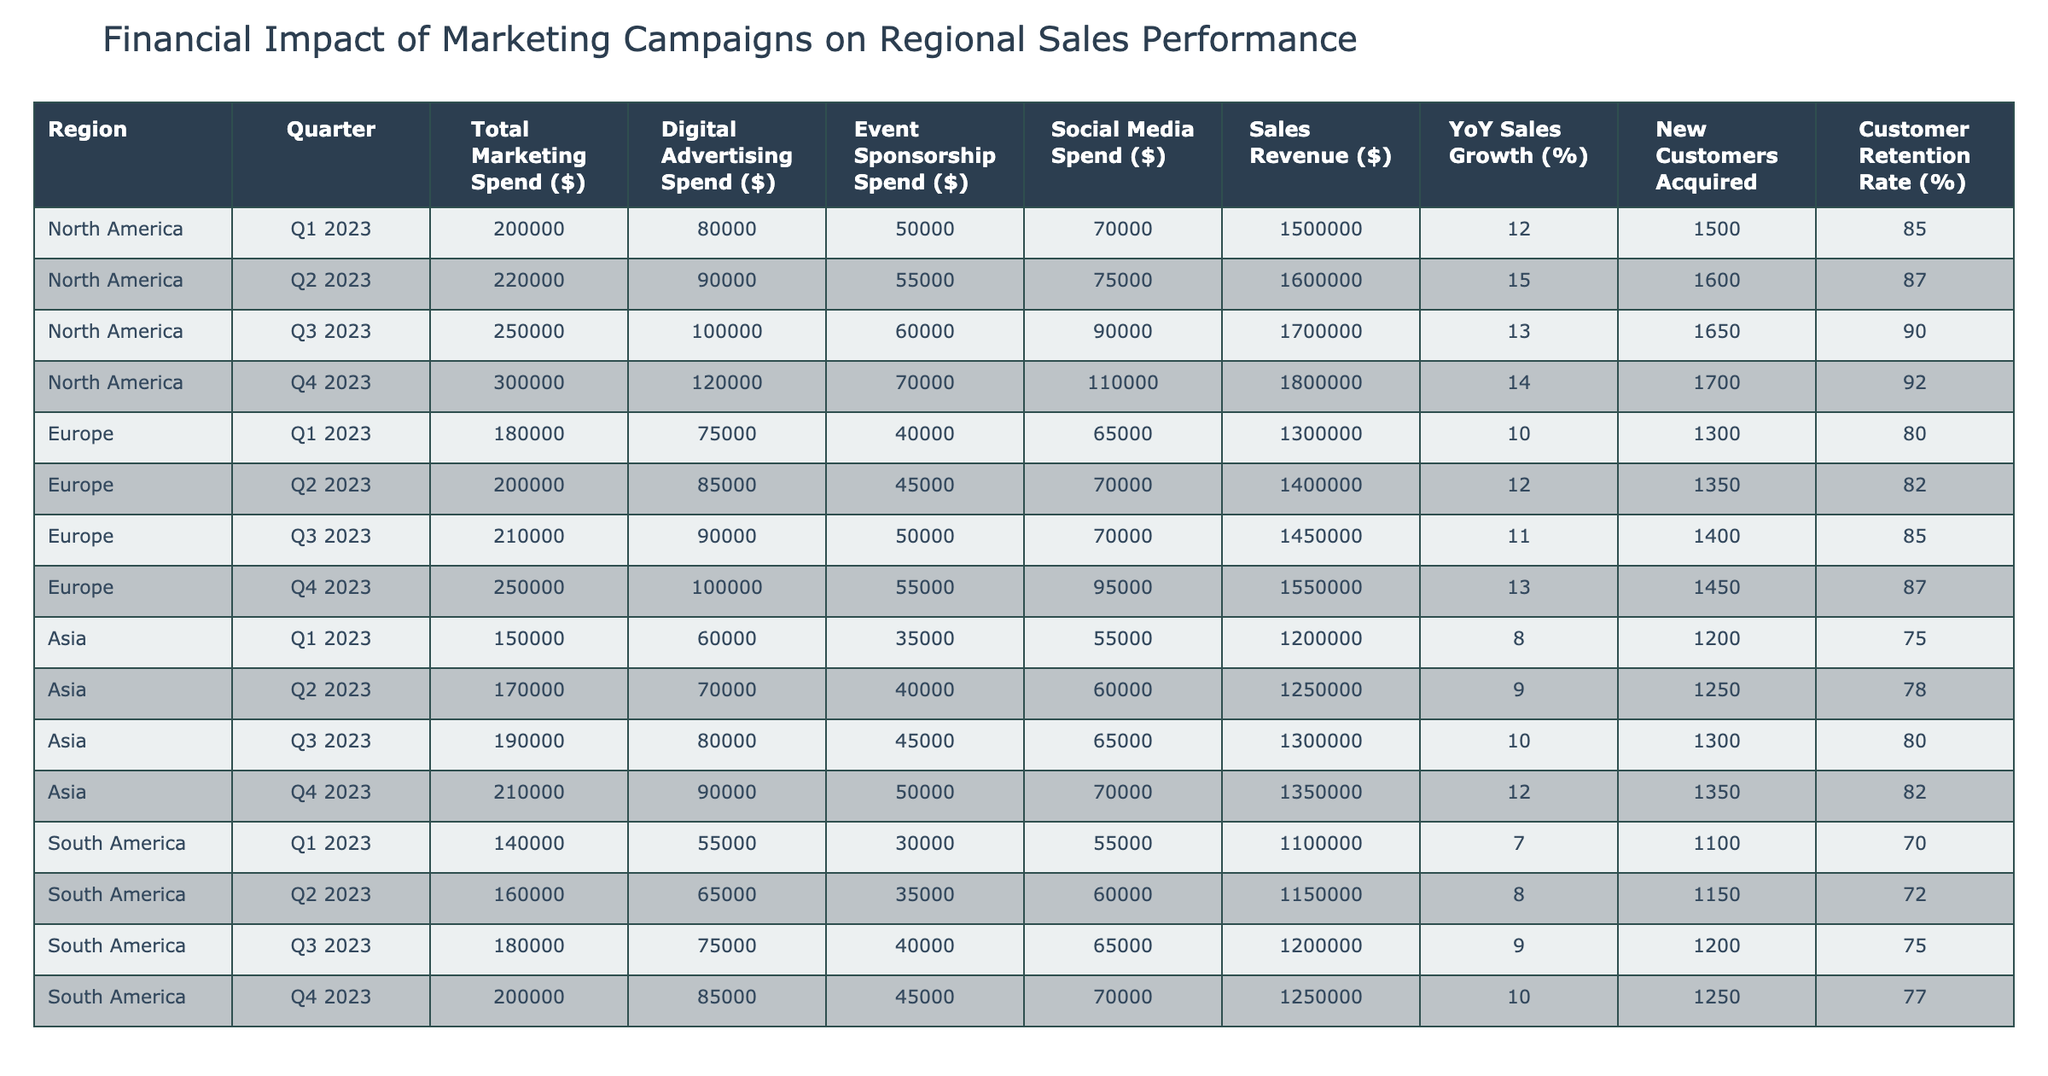What was the total marketing spend in North America for Q2 2023? In the table, we look at the North America row for Q2 2023. The Total Marketing Spend is listed as $220,000.
Answer: 220000 What percentage increase did the Sales Revenue experience in North America from Q1 2023 to Q4 2023? The Sales Revenue in Q1 2023 was $1,500,000 and in Q4 2023 it was $1,800,000. The increase is $1,800,000 - $1,500,000 = $300,000. The percentage increase is ($300,000 / $1,500,000) * 100 = 20%.
Answer: 20% Which region had the highest YoY Sales Growth in Q3 2023? Checking the YoY Sales Growth column, North America had 13%, Europe had 11%, Asia had 10%, and South America had 9% in Q3 2023. North America had the highest value of 13%.
Answer: North America Did South America exceed a total marketing spend of $180,000 in any quarter? Looking at the South America marketing spend values, the amounts are $140,000, $160,000, $180,000, and $200,000 for Q1 through Q4 respectively. $200,000 in Q4 exceeds $180,000.
Answer: Yes What was the average customer retention rate across all quarters for Europe? The retention rates for Europe are 80%, 82%, 85%, and 87%. Summing these gives 80 + 82 + 85 + 87 = 334. To find the average, we divide by the number of quarters, which is 4: 334 / 4 = 83.5%.
Answer: 83.5% How many new customers were acquired in Asia in Q3 2023? Looking at the Asia row for Q3 2023, the New Customers Acquired is noted as 1,300.
Answer: 1300 Was there a decrease in digital advertising spend in any quarter in North America compared to the previous quarter? Checking the Digital Advertising Spend for North America: Q1 is $80,000, Q2 is $90,000, Q3 is $100,000, and Q4 is $120,000. All quarters show an increase.
Answer: No Which quarter had the lowest total marketing spend in Europe? Reviewing the Total Marketing Spend for Europe, the values for each quarter are $180,000, $200,000, $210,000, and $250,000. The lowest is $180,000 in Q1 2023.
Answer: Q1 2023 What was the total sales revenue for South America in Q4 2023 compared to Q1 2023? The Sales Revenue for South America in Q4 2023 is $1,250,000 and for Q1 2023 it is $1,100,000. The difference is $1,250,000 - $1,100,000 = $150,000.
Answer: 150000 